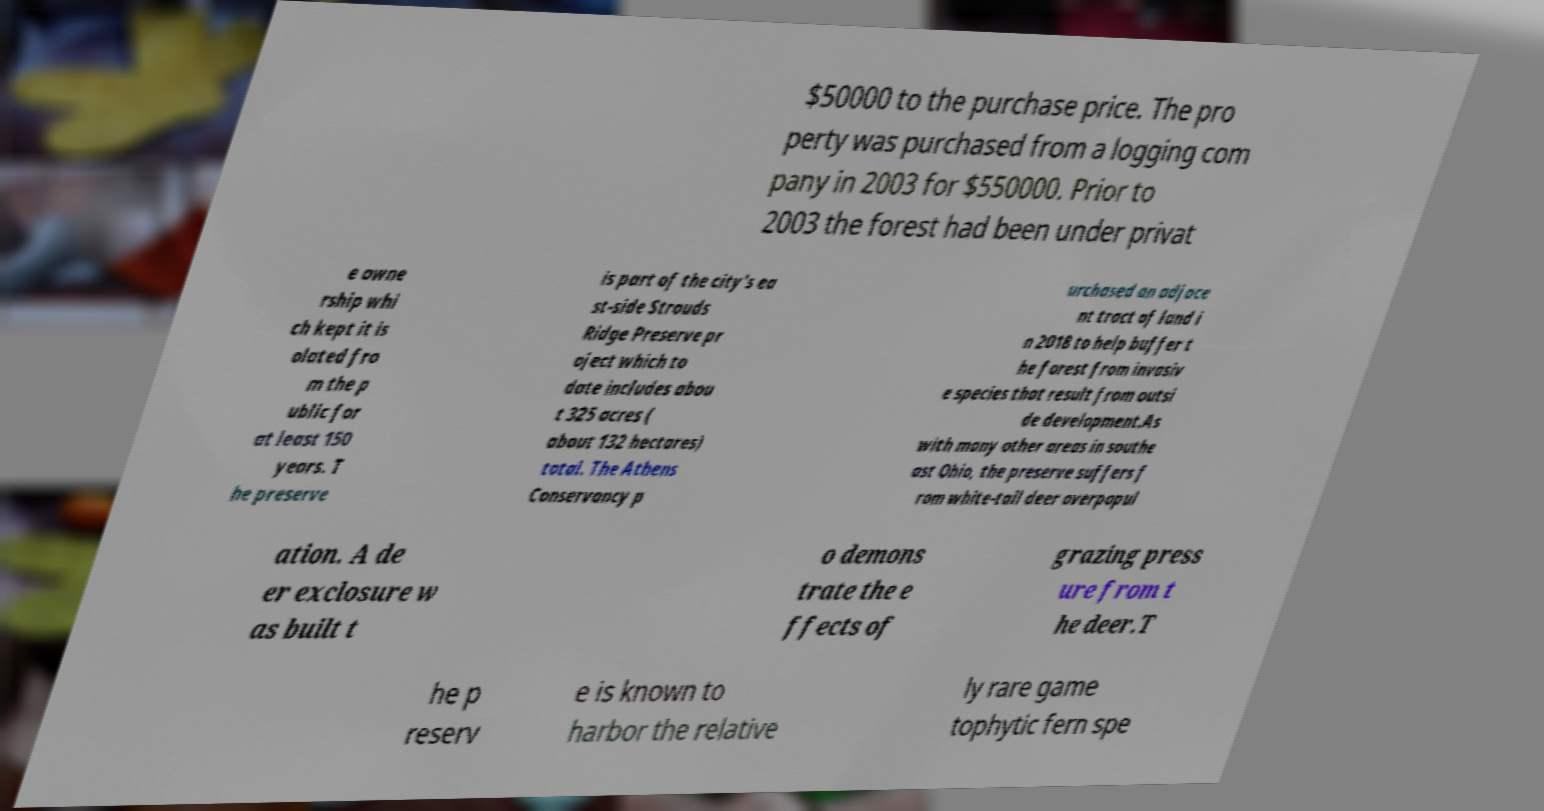What messages or text are displayed in this image? I need them in a readable, typed format. $50000 to the purchase price. The pro perty was purchased from a logging com pany in 2003 for $550000. Prior to 2003 the forest had been under privat e owne rship whi ch kept it is olated fro m the p ublic for at least 150 years. T he preserve is part of the city's ea st-side Strouds Ridge Preserve pr oject which to date includes abou t 325 acres ( about 132 hectares) total. The Athens Conservancy p urchased an adjace nt tract of land i n 2018 to help buffer t he forest from invasiv e species that result from outsi de development.As with many other areas in southe ast Ohio, the preserve suffers f rom white-tail deer overpopul ation. A de er exclosure w as built t o demons trate the e ffects of grazing press ure from t he deer.T he p reserv e is known to harbor the relative ly rare game tophytic fern spe 